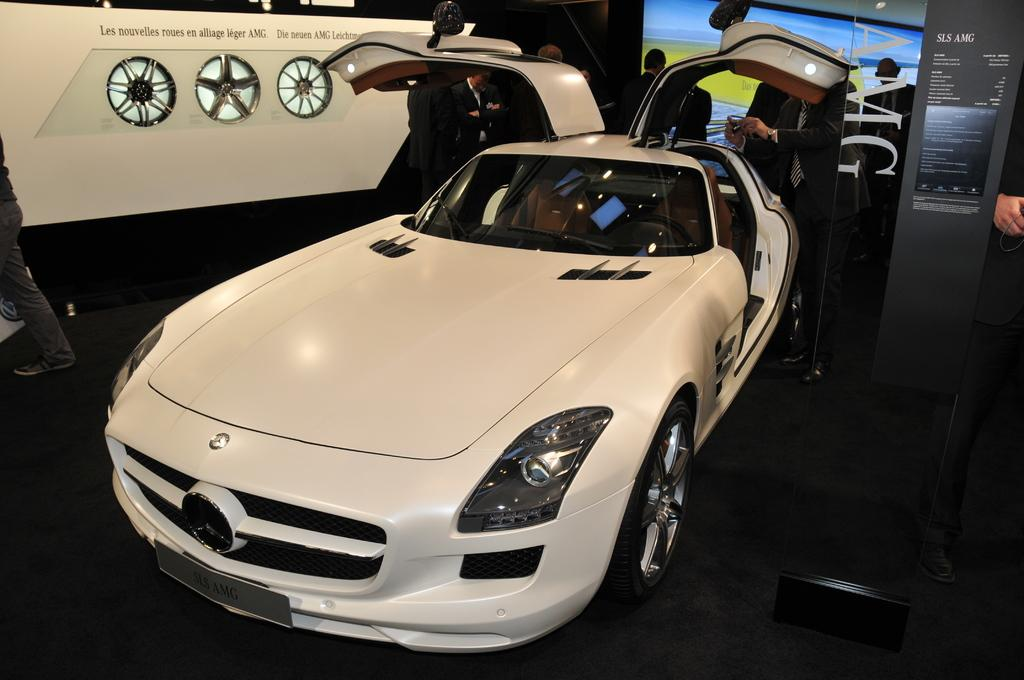What is the main subject of the image? There is a vehicle in the image. What else can be seen in the image besides the vehicle? There are people on the ground in the image. Can you describe the background of the image? There are objects visible in the background of the image. What type of quartz can be seen in the image? There is no quartz present in the image. What thoughts are the people on the ground having in the image? We cannot determine the thoughts of the people in the image based on the provided facts. 